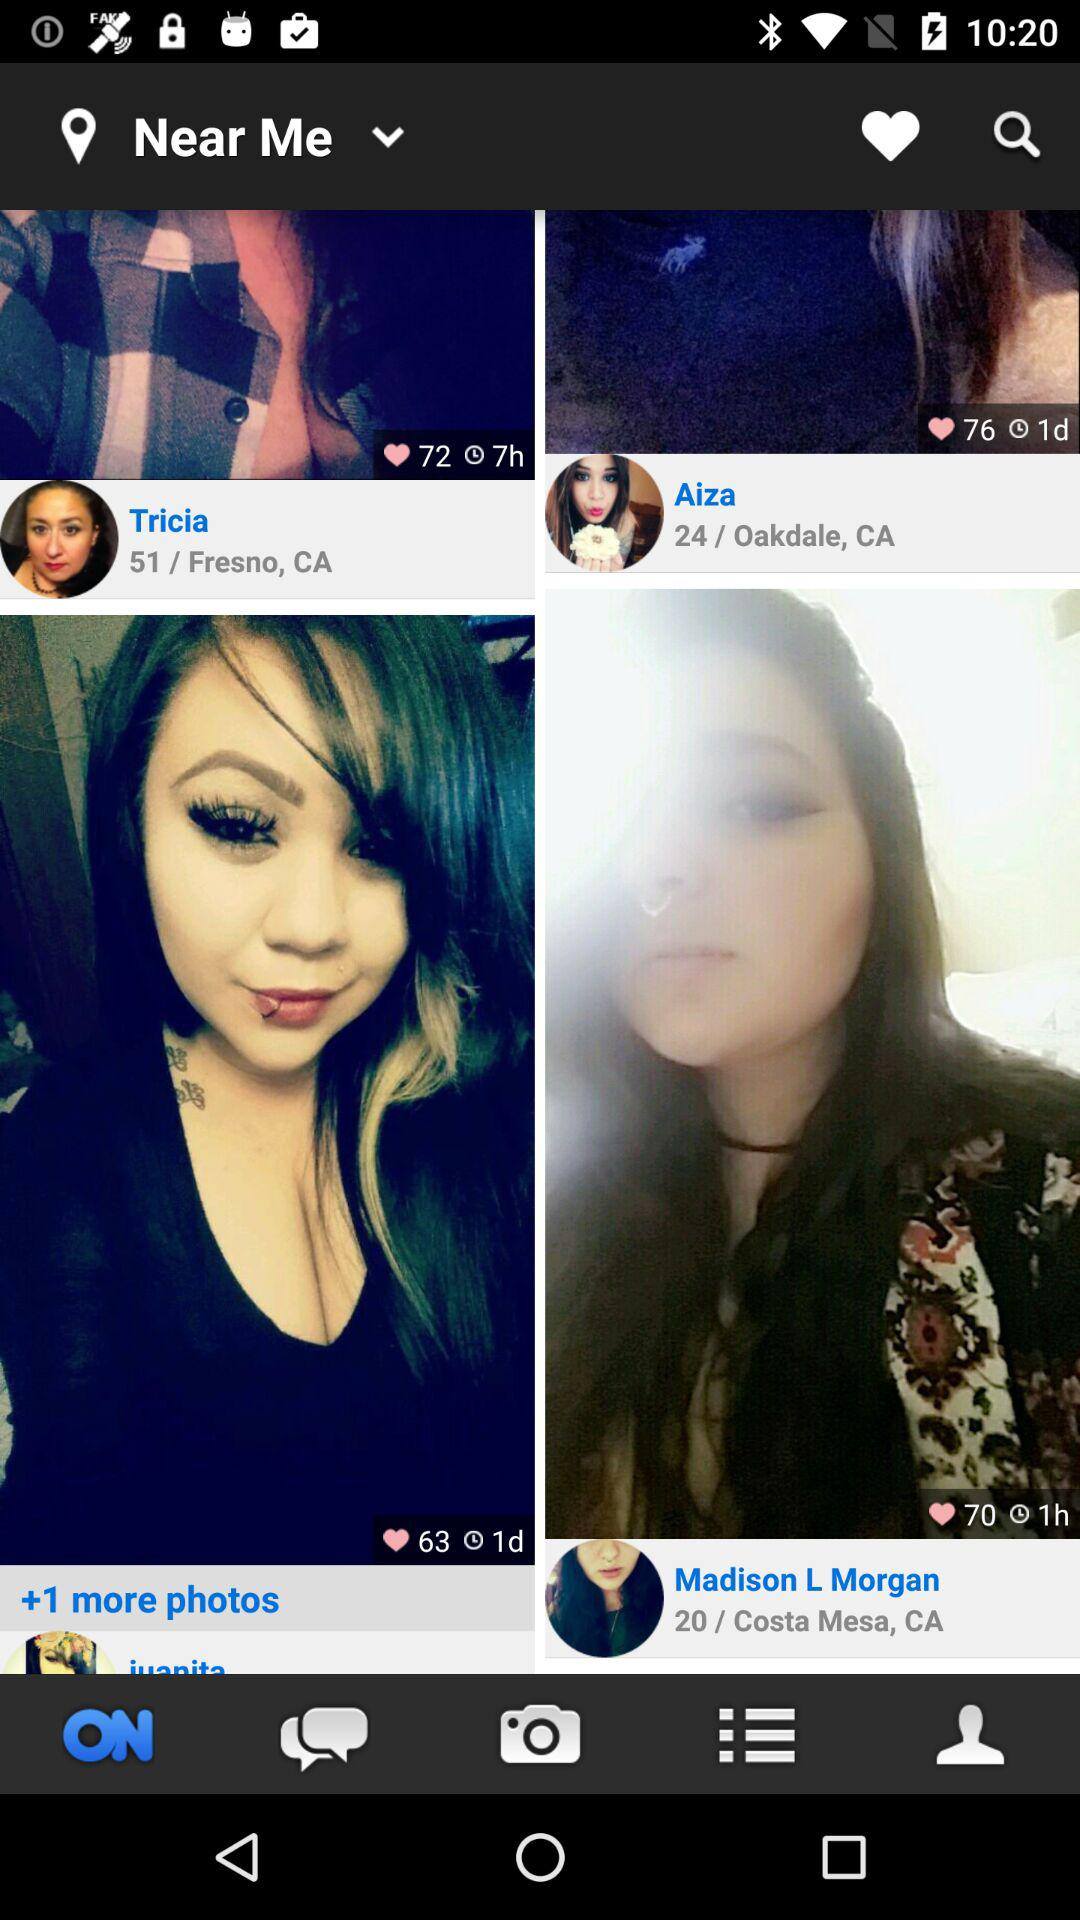What is the age of Tricia? The age of Tricia is 51 years. 